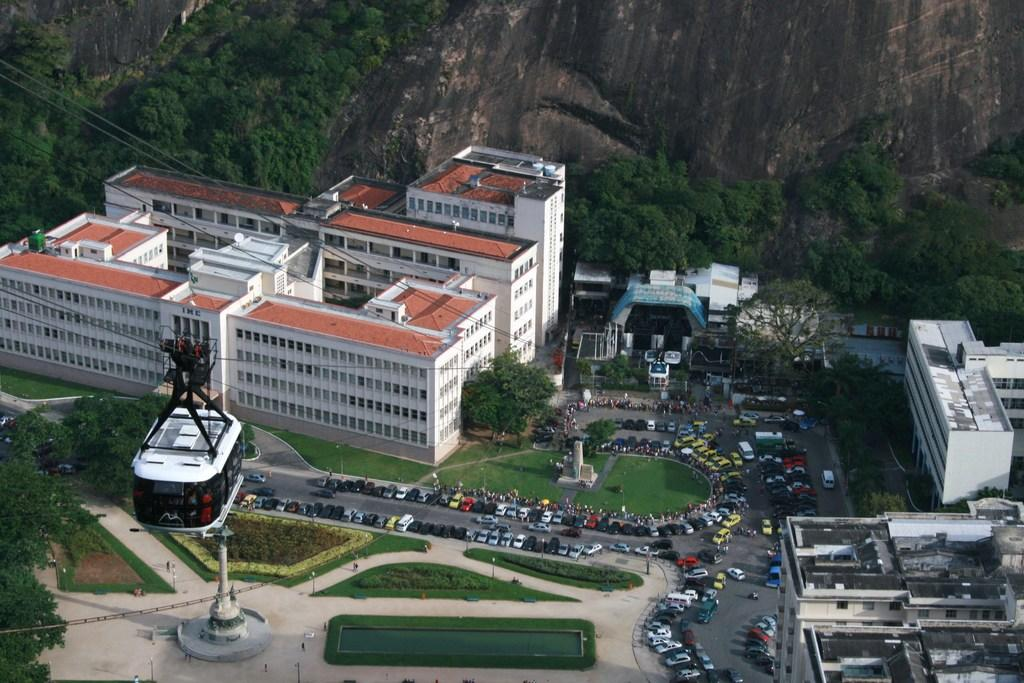What type of natural elements can be seen in the image? There are trees and hills visible in the image. What type of man-made structures are present in the image? There are buildings and a ropeway visible in the image. What type of transportation can be seen in the image? Motor vehicles are visible in the image. What type of water feature is present in the image? There is a fountain in the image. What type of infrastructure is present in the image? There are cables and a road visible in the image. What type of orange is hanging from the trees in the image? There are no oranges present in the image; only trees are visible. What type of clouds can be seen in the image? There are no clouds visible in the image. What type of route is indicated by the cables in the image? The cables in the image are part of a ropeway system, not a route for vehicles or pedestrians. 